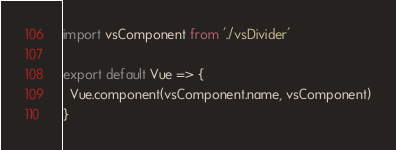<code> <loc_0><loc_0><loc_500><loc_500><_JavaScript_>import vsComponent from './vsDivider'

export default Vue => {
  Vue.component(vsComponent.name, vsComponent)
}
</code> 